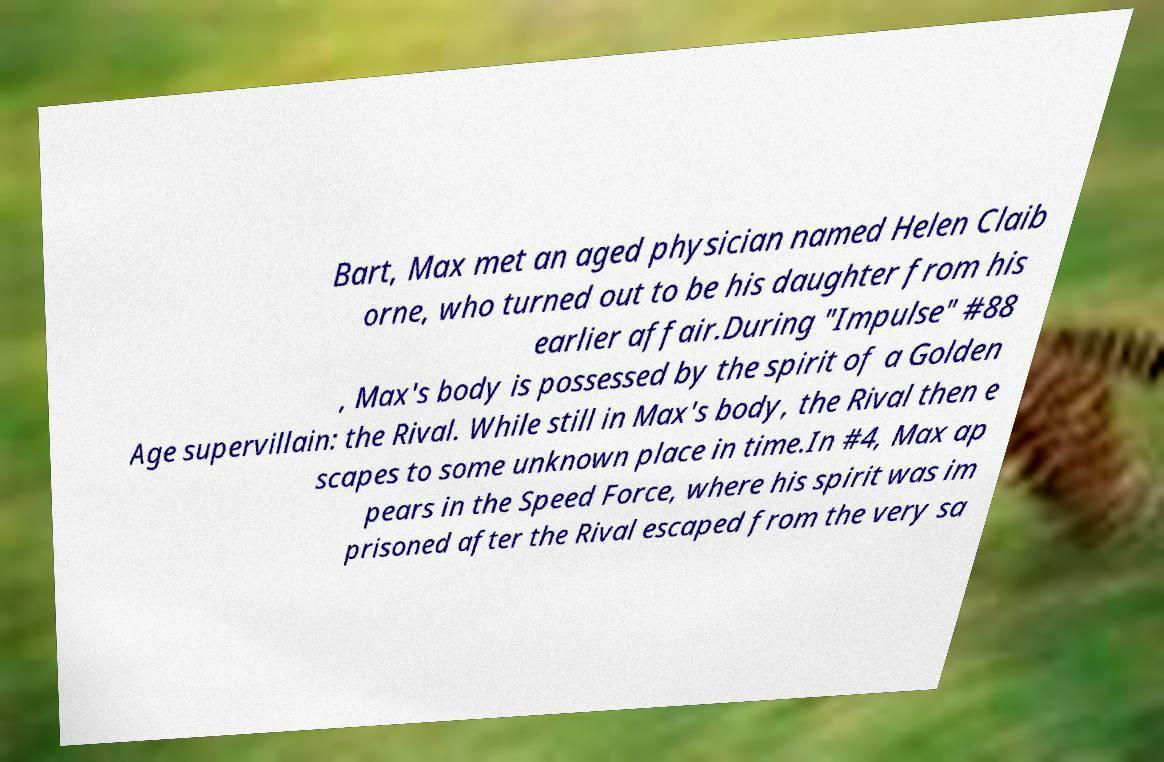For documentation purposes, I need the text within this image transcribed. Could you provide that? Bart, Max met an aged physician named Helen Claib orne, who turned out to be his daughter from his earlier affair.During "Impulse" #88 , Max's body is possessed by the spirit of a Golden Age supervillain: the Rival. While still in Max's body, the Rival then e scapes to some unknown place in time.In #4, Max ap pears in the Speed Force, where his spirit was im prisoned after the Rival escaped from the very sa 